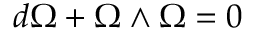Convert formula to latex. <formula><loc_0><loc_0><loc_500><loc_500>d \Omega + \Omega \wedge \Omega = 0</formula> 